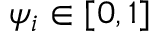Convert formula to latex. <formula><loc_0><loc_0><loc_500><loc_500>\psi _ { i } \in [ 0 , 1 ]</formula> 